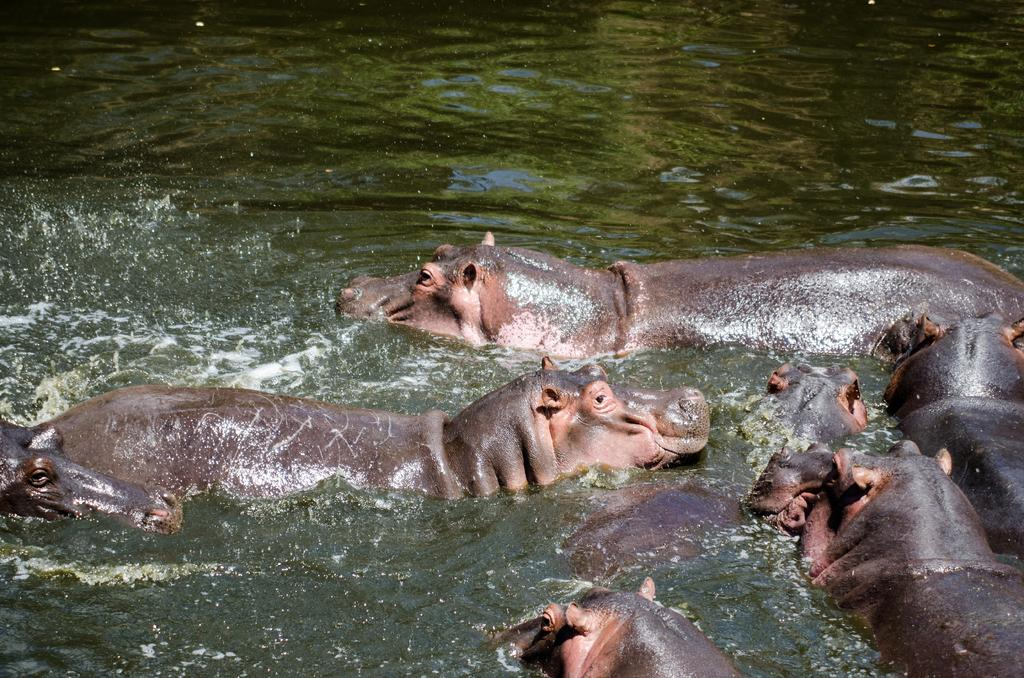What type of animals are present in the image? There are many hippopotamuses in the image. Where are the hippopotamuses located? The hippopotamuses are in the water. How many mice can be seen hiding in the trousers of the hippopotamuses in the image? There are no mice or trousers present in the image; it features hippopotamuses in the water. 